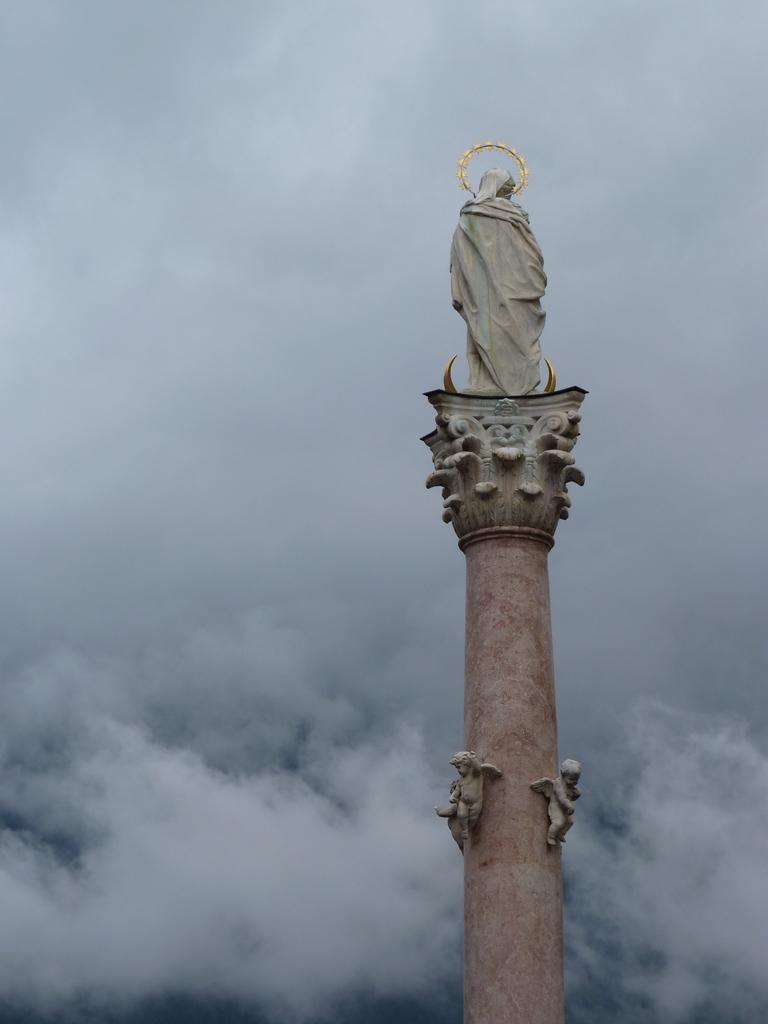What is the main subject of the image? There is a statue in the image. Where is the statue located? The statue is on a tower. What is the color of the statue? The statue is white in color. What colors can be seen in the background of the image? The background of the image includes white and gray colors. What type of game is being played in the image? There is no game being played in the image; it features a statue on a tower. How many pigs can be seen in the image? There are no pigs present in the image. 